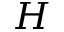Convert formula to latex. <formula><loc_0><loc_0><loc_500><loc_500>H</formula> 